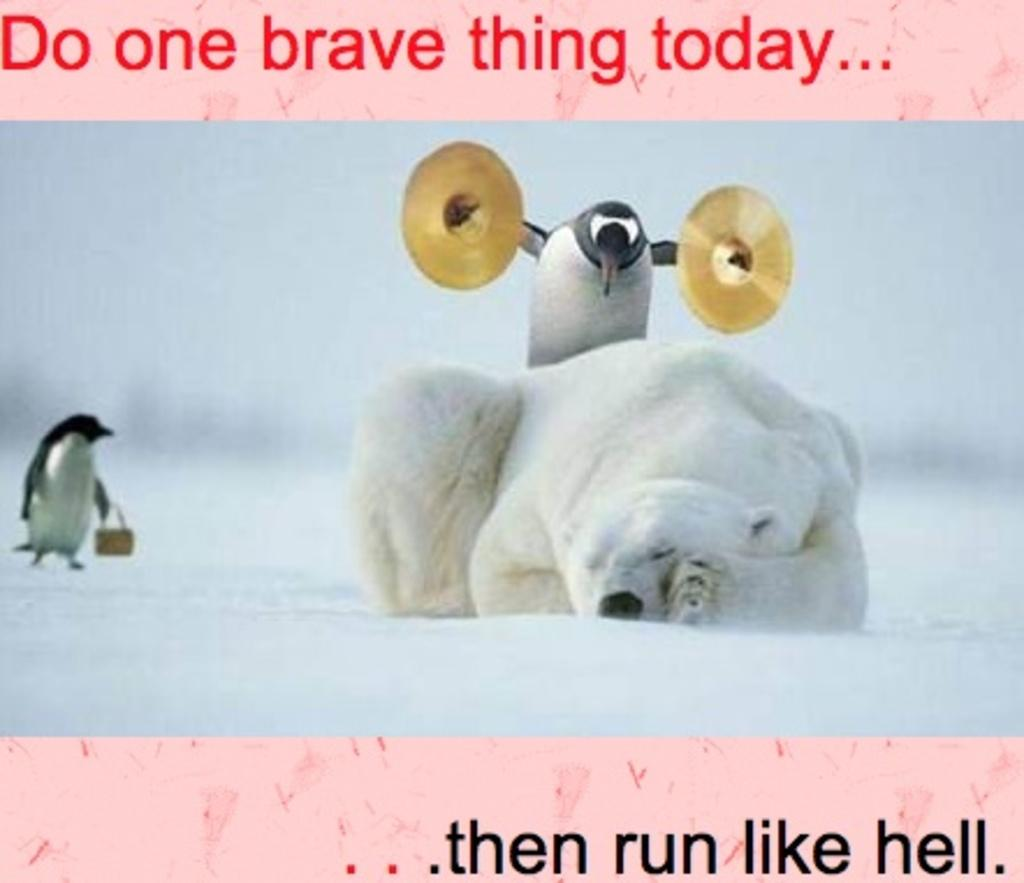What type of animals can be seen in the image? There are penguins and a bear in the image. Where are the animals located? The animals are in the snow. What type of road can be seen in the image? There is no road present in the image; it features penguins, a bear, and snow. What type of holiday is being celebrated in the image? There is no indication of a holiday being celebrated in the image. 